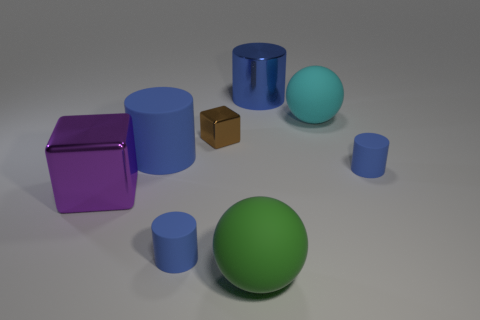Subtract all blue cylinders. How many were subtracted if there are1blue cylinders left? 3 Add 1 big blue spheres. How many objects exist? 9 Subtract all large metal cylinders. How many cylinders are left? 3 Subtract all spheres. How many objects are left? 6 Subtract 1 balls. How many balls are left? 1 Subtract all gray balls. Subtract all brown blocks. How many balls are left? 2 Subtract all brown cubes. How many yellow balls are left? 0 Subtract all rubber things. Subtract all tiny shiny things. How many objects are left? 2 Add 1 large blocks. How many large blocks are left? 2 Add 3 blue cylinders. How many blue cylinders exist? 7 